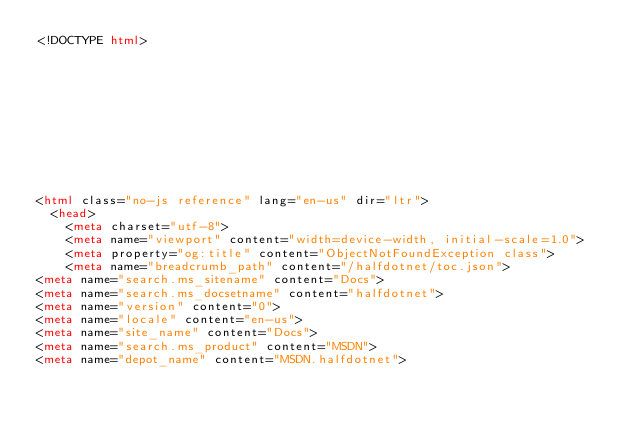Convert code to text. <code><loc_0><loc_0><loc_500><loc_500><_HTML_><!DOCTYPE html>



  


  


  

<html class="no-js reference" lang="en-us" dir="ltr">
  <head>
    <meta charset="utf-8">
    <meta name="viewport" content="width=device-width, initial-scale=1.0">
    <meta property="og:title" content="ObjectNotFoundException class">
    <meta name="breadcrumb_path" content="/halfdotnet/toc.json">
<meta name="search.ms_sitename" content="Docs">
<meta name="search.ms_docsetname" content="halfdotnet">
<meta name="version" content="0">
<meta name="locale" content="en-us">
<meta name="site_name" content="Docs">
<meta name="search.ms_product" content="MSDN">
<meta name="depot_name" content="MSDN.halfdotnet"></code> 